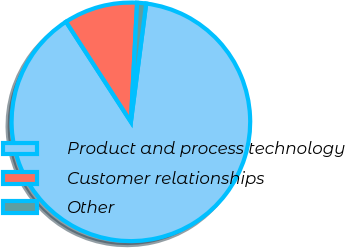Convert chart. <chart><loc_0><loc_0><loc_500><loc_500><pie_chart><fcel>Product and process technology<fcel>Customer relationships<fcel>Other<nl><fcel>88.81%<fcel>9.98%<fcel>1.22%<nl></chart> 